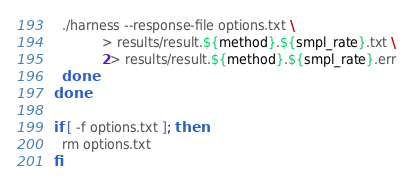<code> <loc_0><loc_0><loc_500><loc_500><_Bash_>  ./harness --response-file options.txt \
            > results/result.${method}.${smpl_rate}.txt \
            2> results/result.${method}.${smpl_rate}.err
  done
done

if [ -f options.txt ]; then
  rm options.txt
fi
</code> 